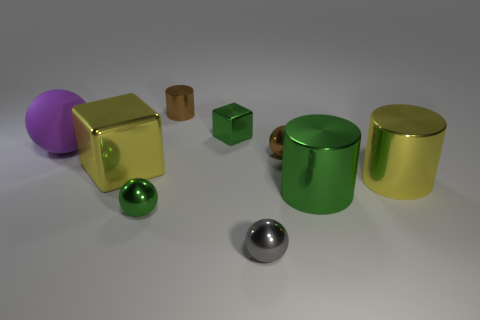Subtract all blue balls. Subtract all brown cylinders. How many balls are left? 4 Add 1 big brown metallic spheres. How many objects exist? 10 Subtract all cylinders. How many objects are left? 6 Subtract all large purple spheres. Subtract all tiny red blocks. How many objects are left? 8 Add 6 small metallic blocks. How many small metallic blocks are left? 7 Add 8 small purple metal blocks. How many small purple metal blocks exist? 8 Subtract 0 cyan blocks. How many objects are left? 9 